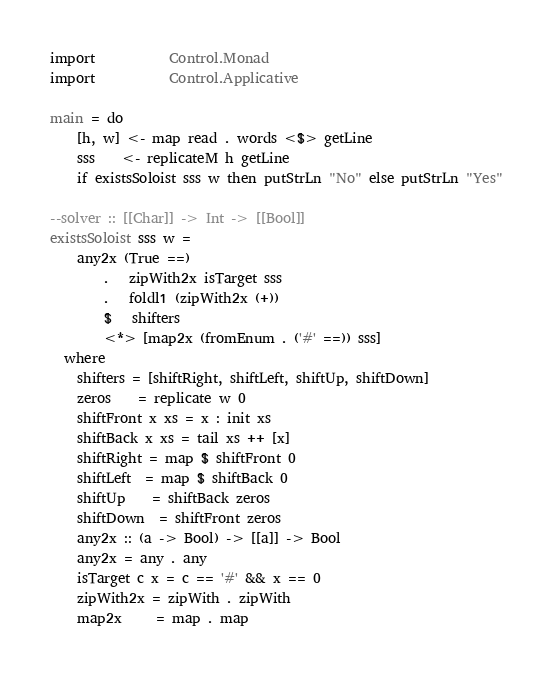<code> <loc_0><loc_0><loc_500><loc_500><_Haskell_>import           Control.Monad
import           Control.Applicative

main = do
    [h, w] <- map read . words <$> getLine
    sss    <- replicateM h getLine
    if existsSoloist sss w then putStrLn "No" else putStrLn "Yes"

--solver :: [[Char]] -> Int -> [[Bool]]
existsSoloist sss w =
    any2x (True ==)
        .   zipWith2x isTarget sss
        .   foldl1 (zipWith2x (+))
        $   shifters
        <*> [map2x (fromEnum . ('#' ==)) sss]
  where
    shifters = [shiftRight, shiftLeft, shiftUp, shiftDown]
    zeros    = replicate w 0
    shiftFront x xs = x : init xs
    shiftBack x xs = tail xs ++ [x]
    shiftRight = map $ shiftFront 0
    shiftLeft  = map $ shiftBack 0
    shiftUp    = shiftBack zeros
    shiftDown  = shiftFront zeros
    any2x :: (a -> Bool) -> [[a]] -> Bool
    any2x = any . any
    isTarget c x = c == '#' && x == 0
    zipWith2x = zipWith . zipWith
    map2x     = map . map
</code> 